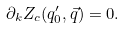Convert formula to latex. <formula><loc_0><loc_0><loc_500><loc_500>\partial _ { k } Z _ { c } ( q ^ { \prime } _ { 0 } , \vec { q } ) = 0 .</formula> 